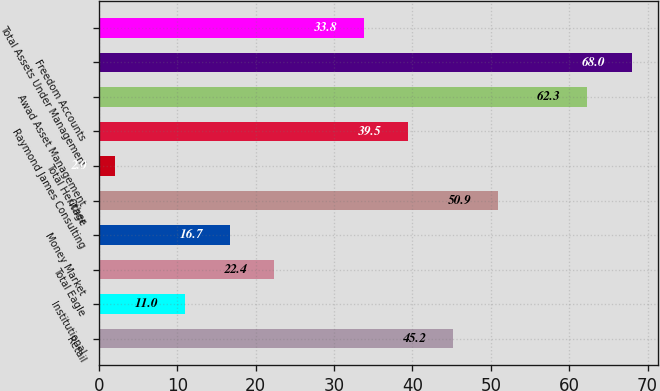Convert chart to OTSL. <chart><loc_0><loc_0><loc_500><loc_500><bar_chart><fcel>Retail<fcel>Institutional<fcel>Total Eagle<fcel>Money Market<fcel>Other<fcel>Total Heritage<fcel>Raymond James Consulting<fcel>Awad Asset Management<fcel>Freedom Accounts<fcel>Total Assets Under Management<nl><fcel>45.2<fcel>11<fcel>22.4<fcel>16.7<fcel>50.9<fcel>2<fcel>39.5<fcel>62.3<fcel>68<fcel>33.8<nl></chart> 